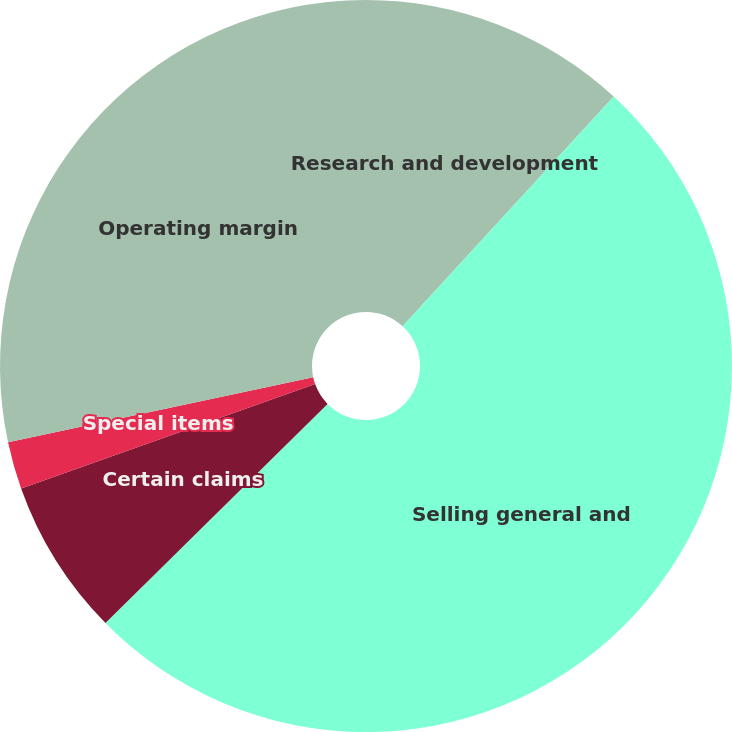Convert chart. <chart><loc_0><loc_0><loc_500><loc_500><pie_chart><fcel>Research and development<fcel>Selling general and<fcel>Certain claims<fcel>Special items<fcel>Operating margin<nl><fcel>11.83%<fcel>50.77%<fcel>6.96%<fcel>2.09%<fcel>28.34%<nl></chart> 